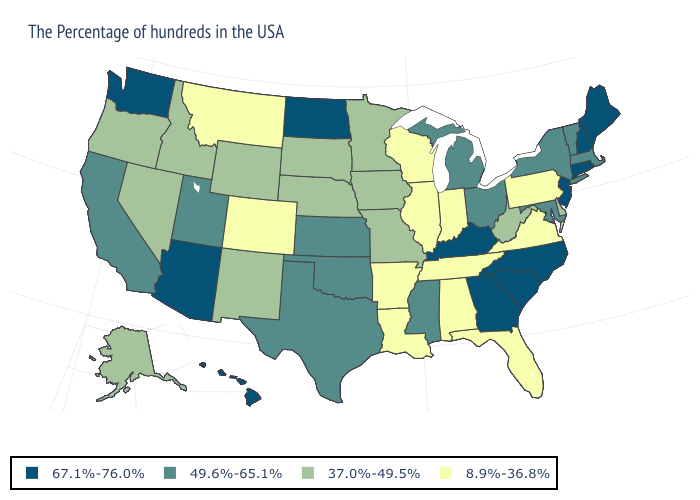What is the lowest value in the USA?
Keep it brief. 8.9%-36.8%. Is the legend a continuous bar?
Short answer required. No. Does the first symbol in the legend represent the smallest category?
Answer briefly. No. Name the states that have a value in the range 8.9%-36.8%?
Answer briefly. Pennsylvania, Virginia, Florida, Indiana, Alabama, Tennessee, Wisconsin, Illinois, Louisiana, Arkansas, Colorado, Montana. Name the states that have a value in the range 8.9%-36.8%?
Short answer required. Pennsylvania, Virginia, Florida, Indiana, Alabama, Tennessee, Wisconsin, Illinois, Louisiana, Arkansas, Colorado, Montana. Name the states that have a value in the range 67.1%-76.0%?
Quick response, please. Maine, Rhode Island, New Hampshire, Connecticut, New Jersey, North Carolina, South Carolina, Georgia, Kentucky, North Dakota, Arizona, Washington, Hawaii. Name the states that have a value in the range 37.0%-49.5%?
Concise answer only. Delaware, West Virginia, Missouri, Minnesota, Iowa, Nebraska, South Dakota, Wyoming, New Mexico, Idaho, Nevada, Oregon, Alaska. What is the value of Wyoming?
Answer briefly. 37.0%-49.5%. What is the value of Massachusetts?
Give a very brief answer. 49.6%-65.1%. Does Vermont have the lowest value in the USA?
Quick response, please. No. Name the states that have a value in the range 49.6%-65.1%?
Quick response, please. Massachusetts, Vermont, New York, Maryland, Ohio, Michigan, Mississippi, Kansas, Oklahoma, Texas, Utah, California. Among the states that border Kansas , which have the lowest value?
Write a very short answer. Colorado. How many symbols are there in the legend?
Concise answer only. 4. How many symbols are there in the legend?
Give a very brief answer. 4. Name the states that have a value in the range 8.9%-36.8%?
Write a very short answer. Pennsylvania, Virginia, Florida, Indiana, Alabama, Tennessee, Wisconsin, Illinois, Louisiana, Arkansas, Colorado, Montana. 